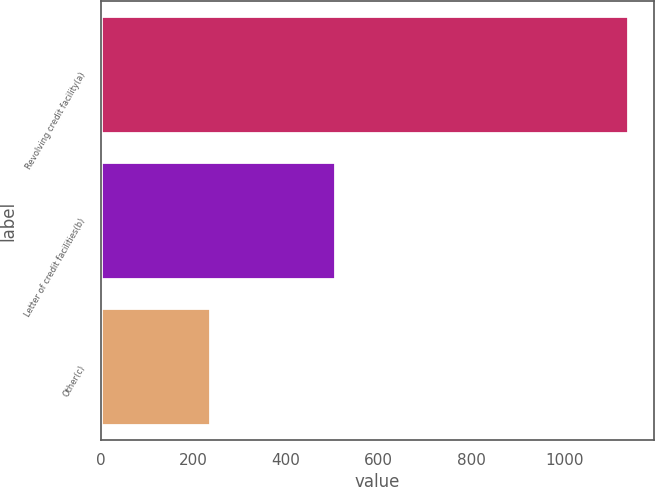<chart> <loc_0><loc_0><loc_500><loc_500><bar_chart><fcel>Revolving credit facility(a)<fcel>Letter of credit facilities(b)<fcel>Other(c)<nl><fcel>1138<fcel>505<fcel>237<nl></chart> 